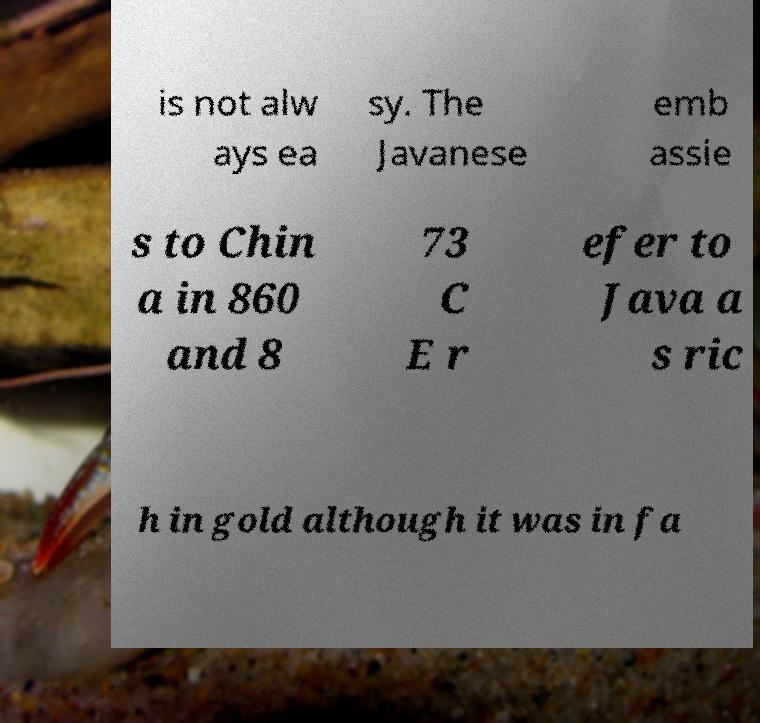What messages or text are displayed in this image? I need them in a readable, typed format. is not alw ays ea sy. The Javanese emb assie s to Chin a in 860 and 8 73 C E r efer to Java a s ric h in gold although it was in fa 